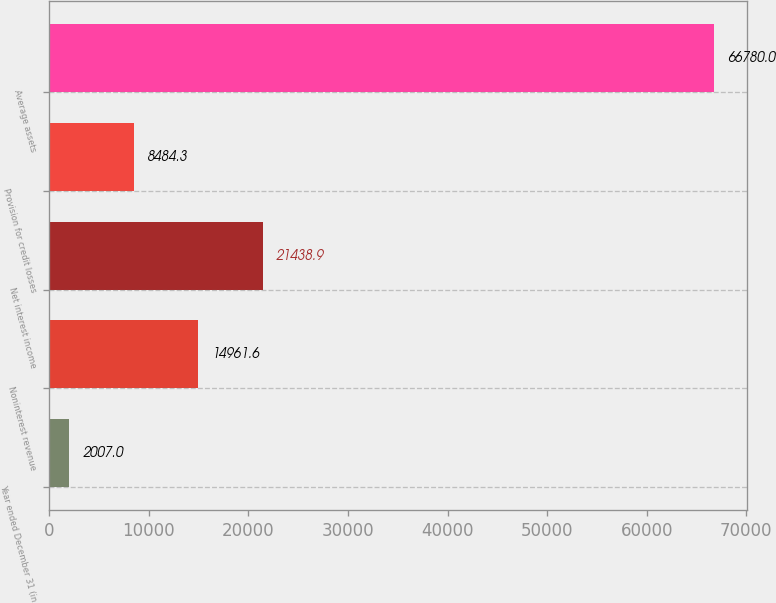Convert chart. <chart><loc_0><loc_0><loc_500><loc_500><bar_chart><fcel>Year ended December 31 (in<fcel>Noninterest revenue<fcel>Net interest income<fcel>Provision for credit losses<fcel>Average assets<nl><fcel>2007<fcel>14961.6<fcel>21438.9<fcel>8484.3<fcel>66780<nl></chart> 